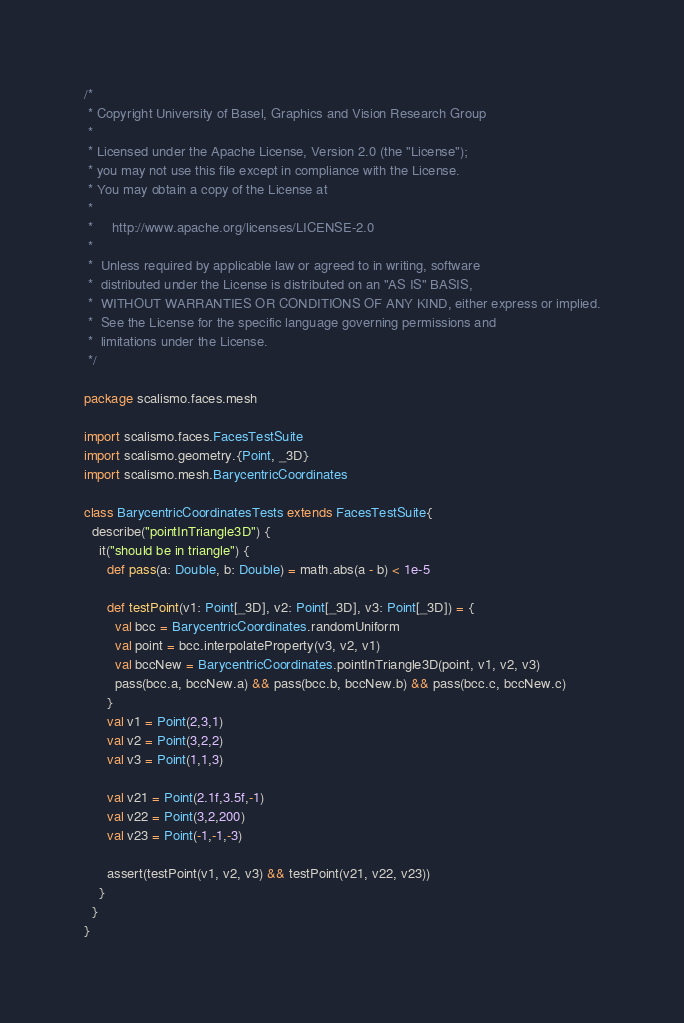<code> <loc_0><loc_0><loc_500><loc_500><_Scala_>/*
 * Copyright University of Basel, Graphics and Vision Research Group
 *
 * Licensed under the Apache License, Version 2.0 (the "License");
 * you may not use this file except in compliance with the License.
 * You may obtain a copy of the License at
 *
 *     http://www.apache.org/licenses/LICENSE-2.0
 *
 *  Unless required by applicable law or agreed to in writing, software
 *  distributed under the License is distributed on an "AS IS" BASIS,
 *  WITHOUT WARRANTIES OR CONDITIONS OF ANY KIND, either express or implied.
 *  See the License for the specific language governing permissions and
 *  limitations under the License.
 */

package scalismo.faces.mesh

import scalismo.faces.FacesTestSuite
import scalismo.geometry.{Point, _3D}
import scalismo.mesh.BarycentricCoordinates

class BarycentricCoordinatesTests extends FacesTestSuite{
  describe("pointInTriangle3D") {
    it("should be in triangle") {
      def pass(a: Double, b: Double) = math.abs(a - b) < 1e-5

      def testPoint(v1: Point[_3D], v2: Point[_3D], v3: Point[_3D]) = {
        val bcc = BarycentricCoordinates.randomUniform
        val point = bcc.interpolateProperty(v3, v2, v1)
        val bccNew = BarycentricCoordinates.pointInTriangle3D(point, v1, v2, v3)
        pass(bcc.a, bccNew.a) && pass(bcc.b, bccNew.b) && pass(bcc.c, bccNew.c)
      }
      val v1 = Point(2,3,1)
      val v2 = Point(3,2,2)
      val v3 = Point(1,1,3)

      val v21 = Point(2.1f,3.5f,-1)
      val v22 = Point(3,2,200)
      val v23 = Point(-1,-1,-3)

      assert(testPoint(v1, v2, v3) && testPoint(v21, v22, v23))
    }
  }
}
</code> 